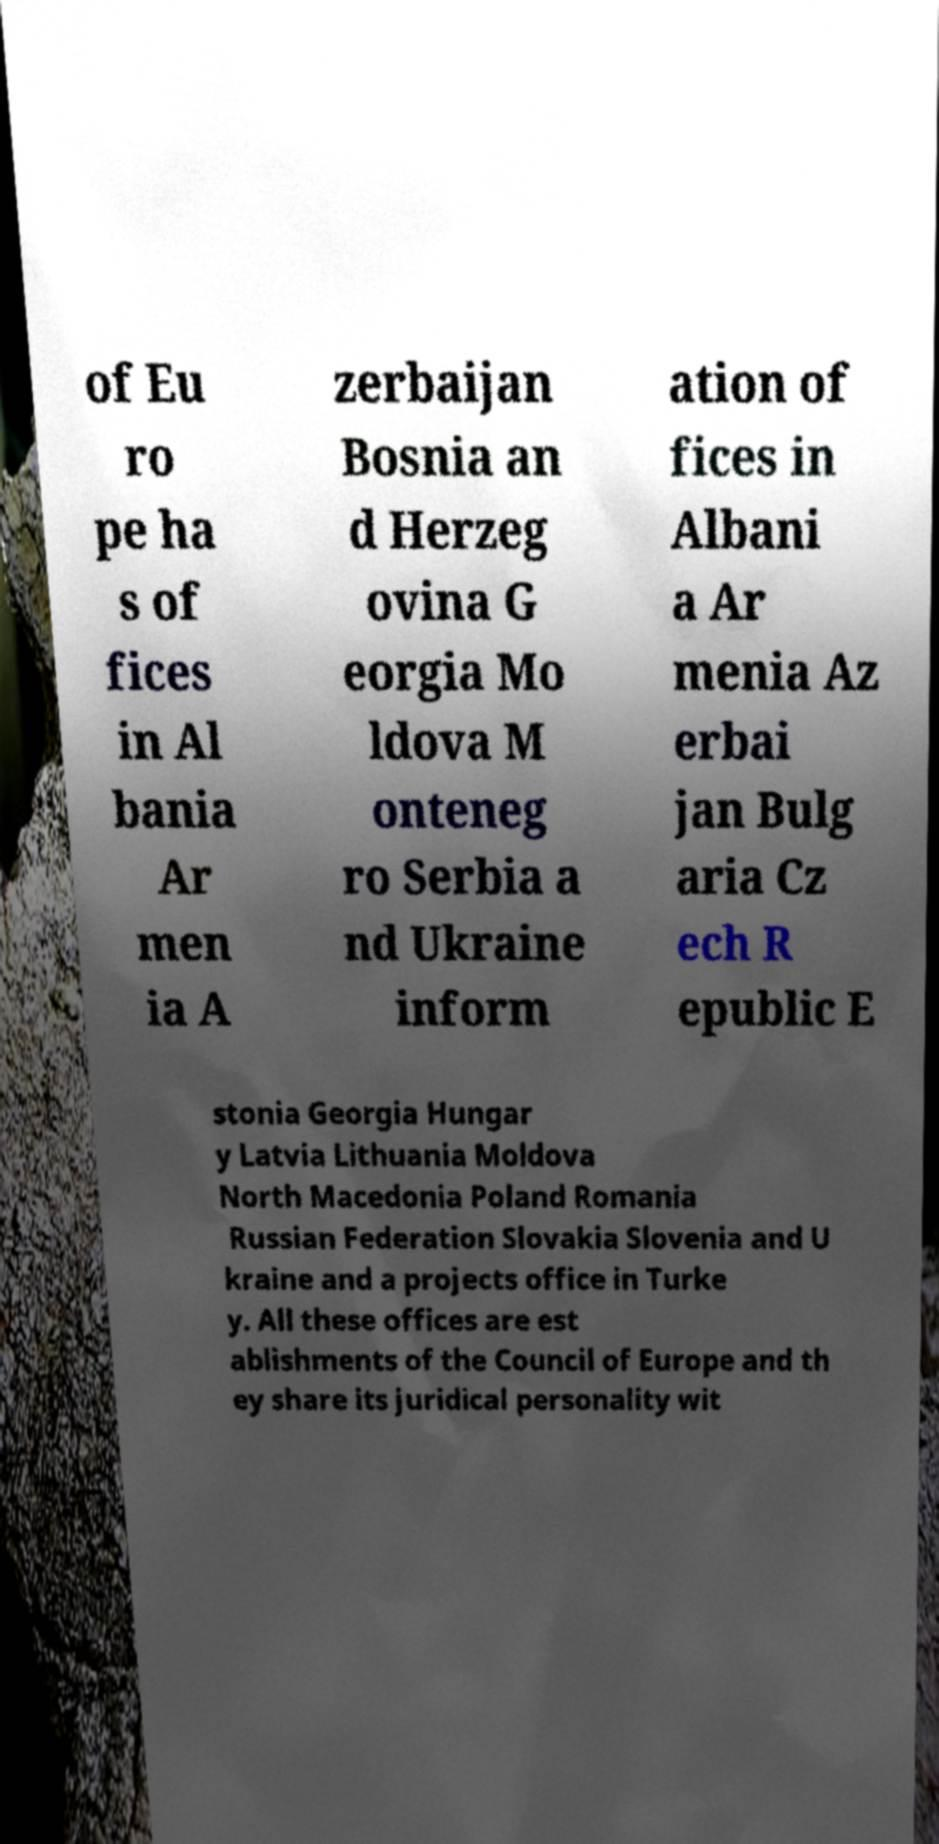For documentation purposes, I need the text within this image transcribed. Could you provide that? of Eu ro pe ha s of fices in Al bania Ar men ia A zerbaijan Bosnia an d Herzeg ovina G eorgia Mo ldova M onteneg ro Serbia a nd Ukraine inform ation of fices in Albani a Ar menia Az erbai jan Bulg aria Cz ech R epublic E stonia Georgia Hungar y Latvia Lithuania Moldova North Macedonia Poland Romania Russian Federation Slovakia Slovenia and U kraine and a projects office in Turke y. All these offices are est ablishments of the Council of Europe and th ey share its juridical personality wit 